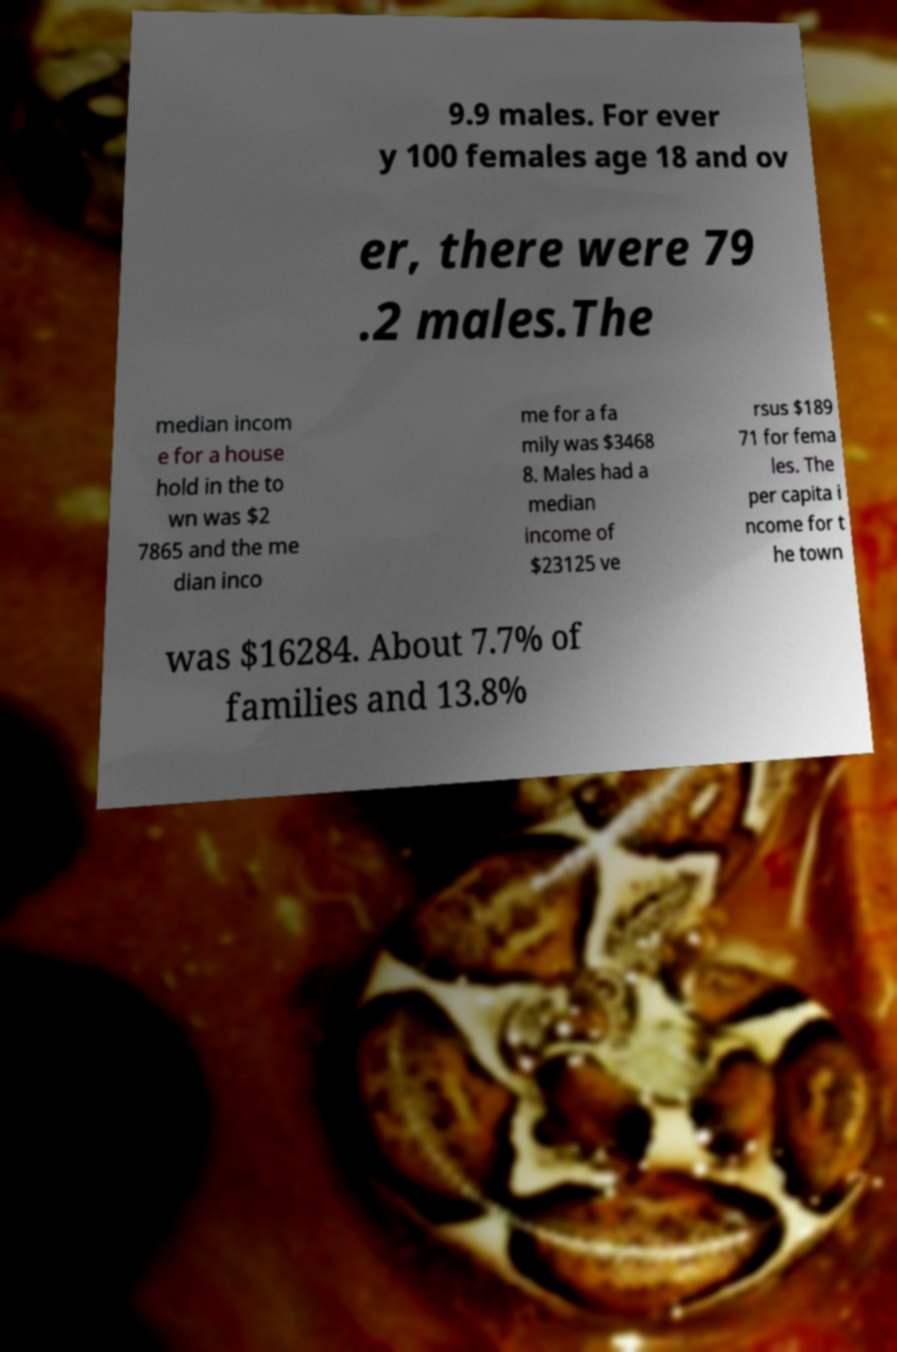Could you assist in decoding the text presented in this image and type it out clearly? 9.9 males. For ever y 100 females age 18 and ov er, there were 79 .2 males.The median incom e for a house hold in the to wn was $2 7865 and the me dian inco me for a fa mily was $3468 8. Males had a median income of $23125 ve rsus $189 71 for fema les. The per capita i ncome for t he town was $16284. About 7.7% of families and 13.8% 